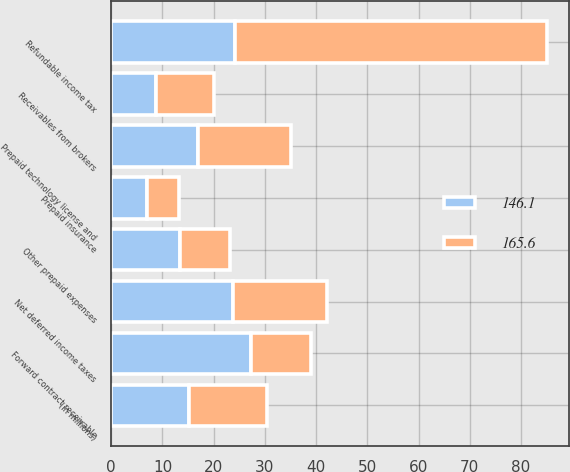Convert chart. <chart><loc_0><loc_0><loc_500><loc_500><stacked_bar_chart><ecel><fcel>(in millions)<fcel>Refundable income tax<fcel>Net deferred income taxes<fcel>Prepaid technology license and<fcel>Forward contract receivable<fcel>Receivables from brokers<fcel>Other prepaid expenses<fcel>Prepaid insurance<nl><fcel>165.6<fcel>15.25<fcel>61<fcel>18.3<fcel>18<fcel>11.8<fcel>11.2<fcel>9.6<fcel>6.3<nl><fcel>146.1<fcel>15.25<fcel>24.1<fcel>23.8<fcel>17<fcel>27.3<fcel>8.8<fcel>13.5<fcel>7<nl></chart> 